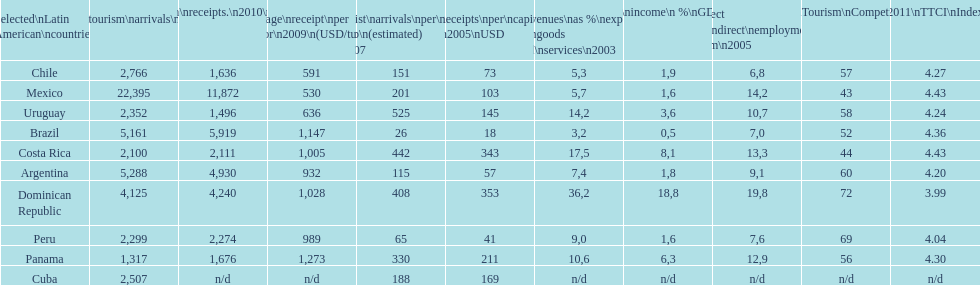What was the count of international travelers (x1000) visiting mexico in 2010? 22,395. 